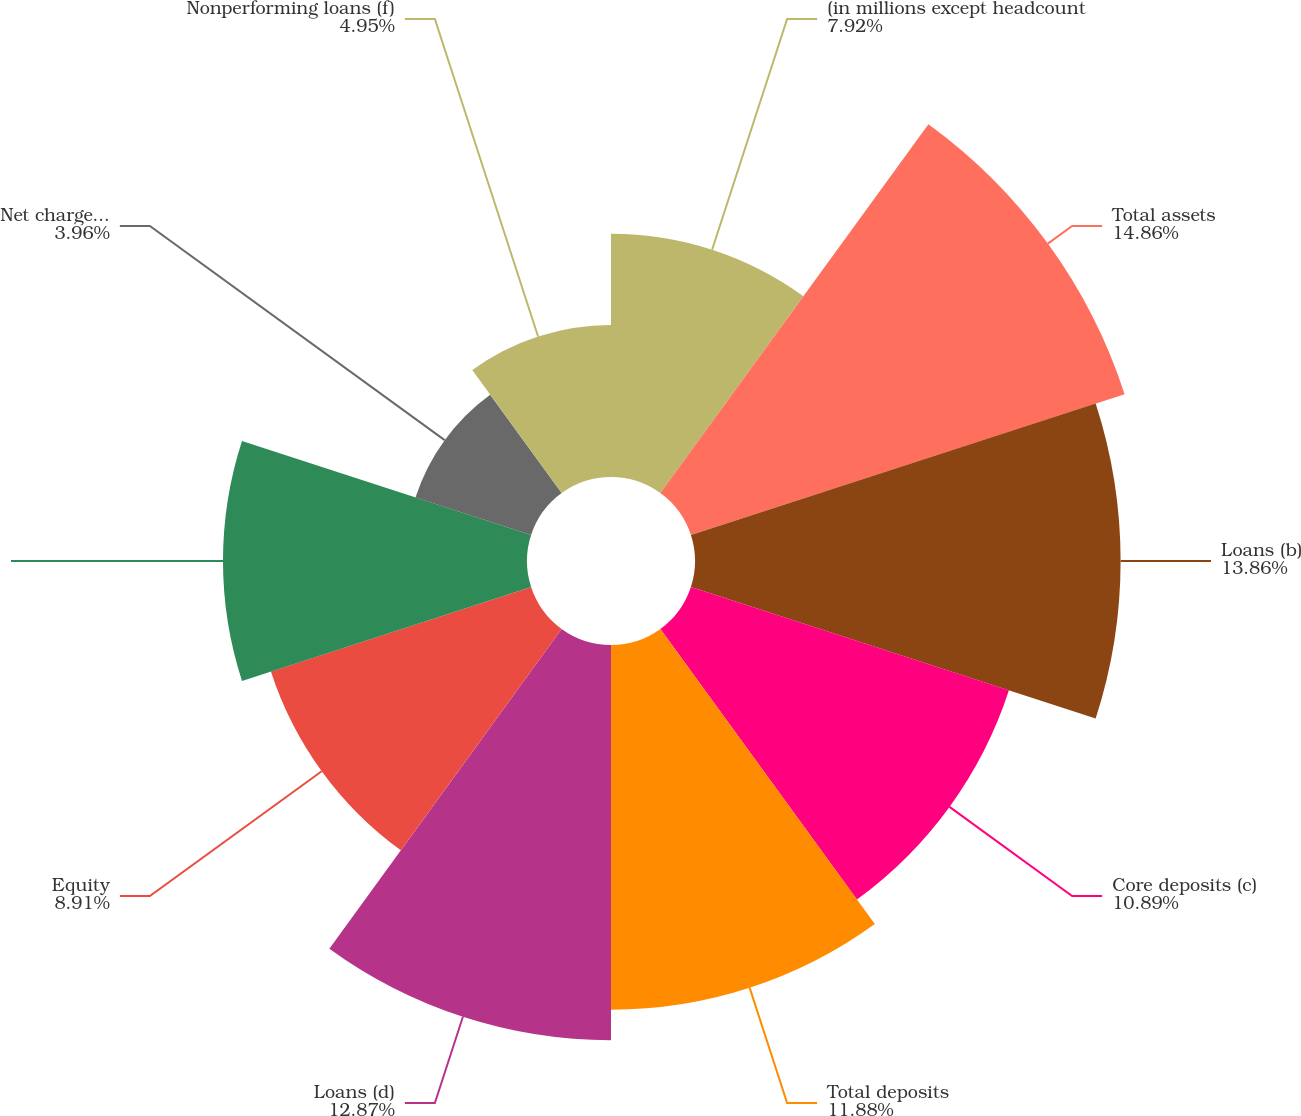<chart> <loc_0><loc_0><loc_500><loc_500><pie_chart><fcel>(in millions except headcount<fcel>Total assets<fcel>Loans (b)<fcel>Core deposits (c)<fcel>Total deposits<fcel>Loans (d)<fcel>Equity<fcel>Headcount<fcel>Net charge-offs (e)<fcel>Nonperforming loans (f)<nl><fcel>7.92%<fcel>14.85%<fcel>13.86%<fcel>10.89%<fcel>11.88%<fcel>12.87%<fcel>8.91%<fcel>9.9%<fcel>3.96%<fcel>4.95%<nl></chart> 